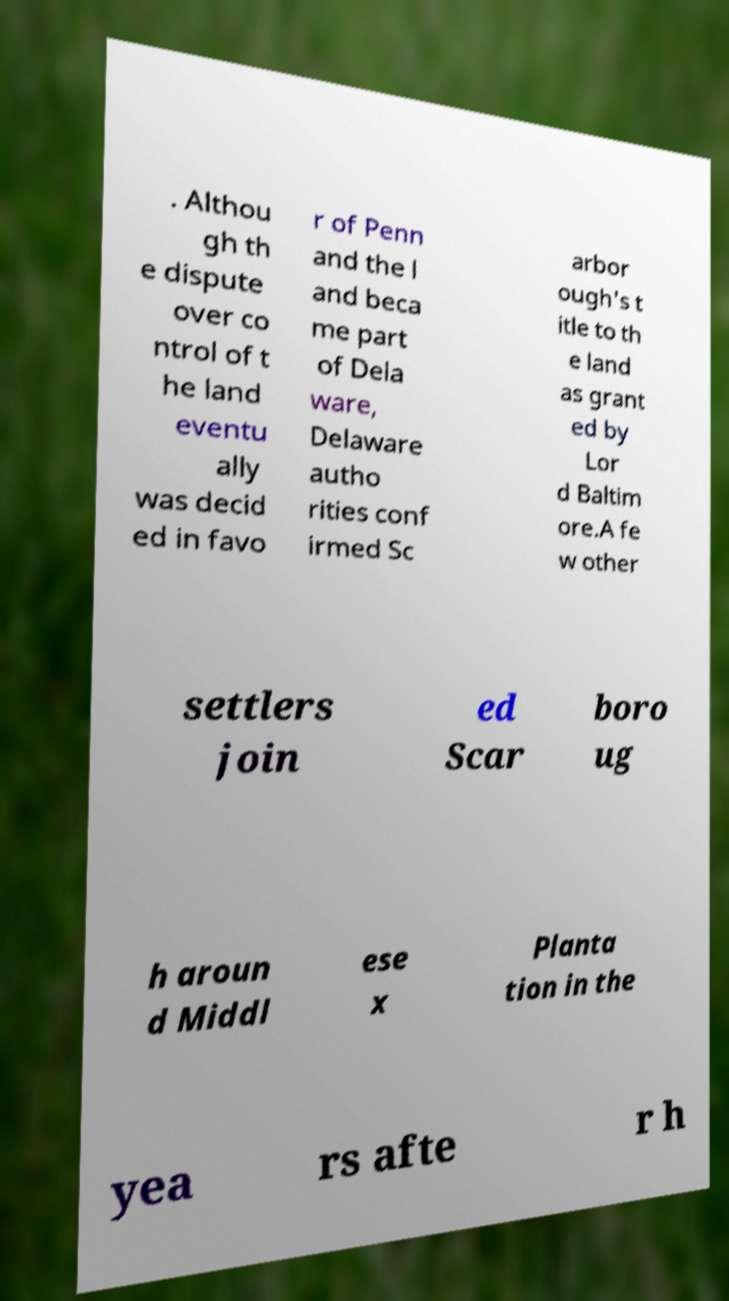Could you assist in decoding the text presented in this image and type it out clearly? . Althou gh th e dispute over co ntrol of t he land eventu ally was decid ed in favo r of Penn and the l and beca me part of Dela ware, Delaware autho rities conf irmed Sc arbor ough's t itle to th e land as grant ed by Lor d Baltim ore.A fe w other settlers join ed Scar boro ug h aroun d Middl ese x Planta tion in the yea rs afte r h 